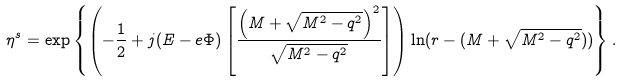Convert formula to latex. <formula><loc_0><loc_0><loc_500><loc_500>\eta ^ { s } = \exp \left \{ \left ( - \frac { 1 } { 2 } + j ( E - e \Phi ) \left [ \frac { \left ( M + \sqrt { M ^ { 2 } - q ^ { 2 } } \right ) ^ { 2 } } { \sqrt { M ^ { 2 } - q ^ { 2 } } } \right ] \right ) \ln ( r - ( M + \sqrt { M ^ { 2 } - q ^ { 2 } } ) ) \right \} .</formula> 